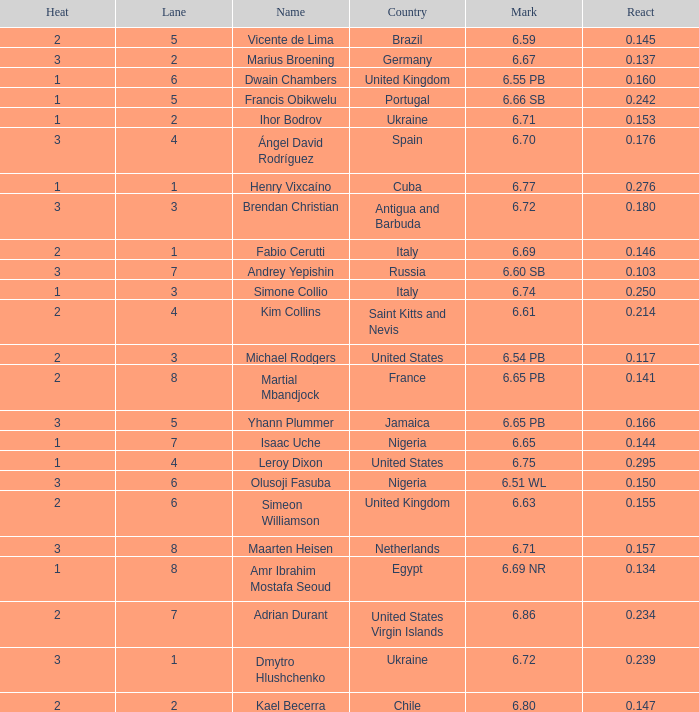What is Heat, when Mark is 6.69? 2.0. 